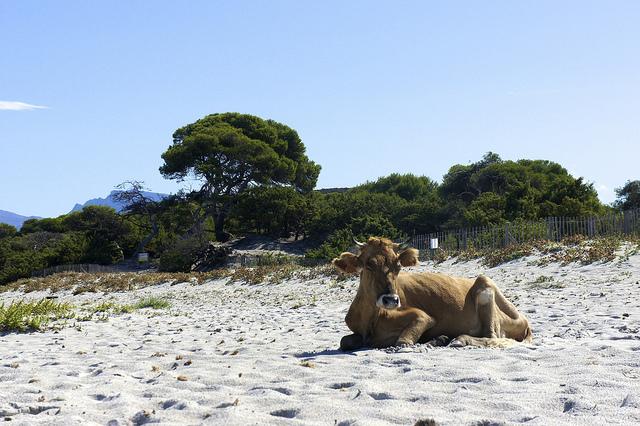Is this animal hurt or just resting?
Give a very brief answer. Resting. What color are the trees?
Quick response, please. Green. What is the ground covered with?
Quick response, please. Sand. 